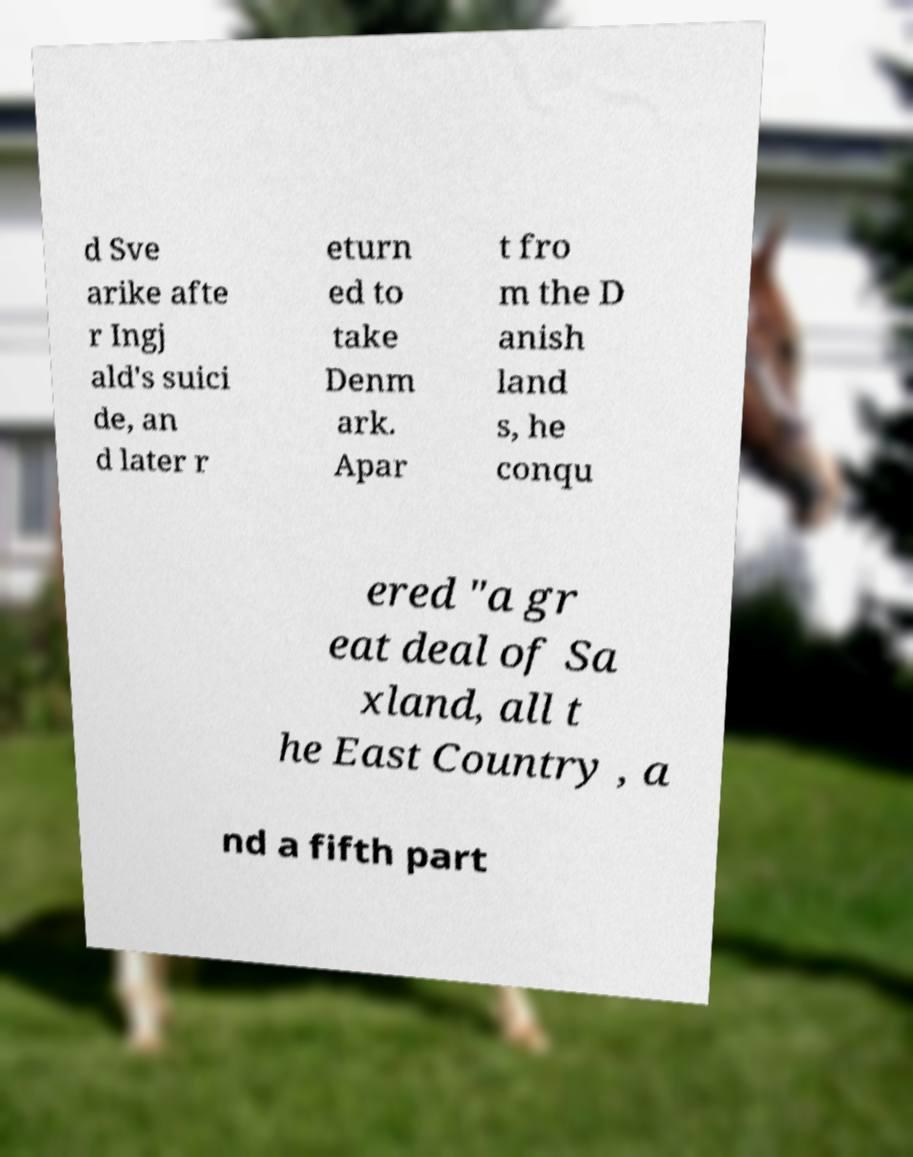Can you read and provide the text displayed in the image?This photo seems to have some interesting text. Can you extract and type it out for me? d Sve arike afte r Ingj ald's suici de, an d later r eturn ed to take Denm ark. Apar t fro m the D anish land s, he conqu ered "a gr eat deal of Sa xland, all t he East Country , a nd a fifth part 